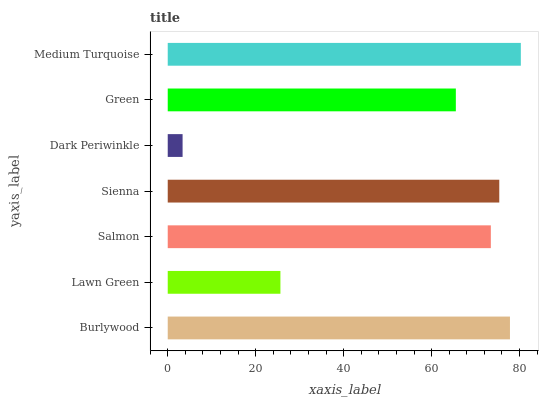Is Dark Periwinkle the minimum?
Answer yes or no. Yes. Is Medium Turquoise the maximum?
Answer yes or no. Yes. Is Lawn Green the minimum?
Answer yes or no. No. Is Lawn Green the maximum?
Answer yes or no. No. Is Burlywood greater than Lawn Green?
Answer yes or no. Yes. Is Lawn Green less than Burlywood?
Answer yes or no. Yes. Is Lawn Green greater than Burlywood?
Answer yes or no. No. Is Burlywood less than Lawn Green?
Answer yes or no. No. Is Salmon the high median?
Answer yes or no. Yes. Is Salmon the low median?
Answer yes or no. Yes. Is Sienna the high median?
Answer yes or no. No. Is Sienna the low median?
Answer yes or no. No. 